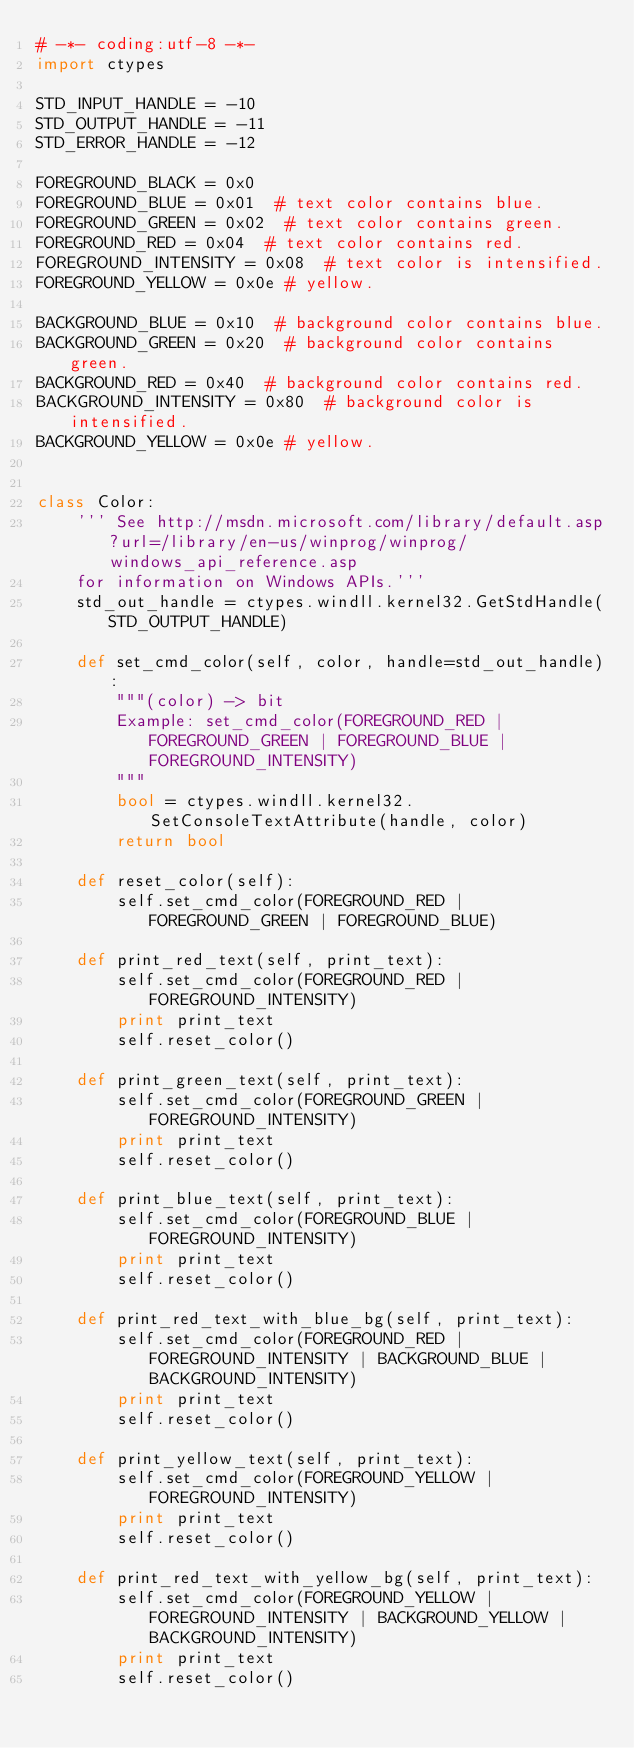Convert code to text. <code><loc_0><loc_0><loc_500><loc_500><_Python_># -*- coding:utf-8 -*-
import ctypes

STD_INPUT_HANDLE = -10
STD_OUTPUT_HANDLE = -11
STD_ERROR_HANDLE = -12

FOREGROUND_BLACK = 0x0
FOREGROUND_BLUE = 0x01  # text color contains blue.
FOREGROUND_GREEN = 0x02  # text color contains green.
FOREGROUND_RED = 0x04  # text color contains red.
FOREGROUND_INTENSITY = 0x08  # text color is intensified.
FOREGROUND_YELLOW = 0x0e # yellow.

BACKGROUND_BLUE = 0x10  # background color contains blue.
BACKGROUND_GREEN = 0x20  # background color contains green.
BACKGROUND_RED = 0x40  # background color contains red.
BACKGROUND_INTENSITY = 0x80  # background color is intensified.
BACKGROUND_YELLOW = 0x0e # yellow.


class Color:
    ''' See http://msdn.microsoft.com/library/default.asp?url=/library/en-us/winprog/winprog/windows_api_reference.asp
    for information on Windows APIs.'''
    std_out_handle = ctypes.windll.kernel32.GetStdHandle(STD_OUTPUT_HANDLE)

    def set_cmd_color(self, color, handle=std_out_handle):
        """(color) -> bit
        Example: set_cmd_color(FOREGROUND_RED | FOREGROUND_GREEN | FOREGROUND_BLUE | FOREGROUND_INTENSITY)
        """
        bool = ctypes.windll.kernel32.SetConsoleTextAttribute(handle, color)
        return bool

    def reset_color(self):
        self.set_cmd_color(FOREGROUND_RED | FOREGROUND_GREEN | FOREGROUND_BLUE)

    def print_red_text(self, print_text):
        self.set_cmd_color(FOREGROUND_RED | FOREGROUND_INTENSITY)
        print print_text
        self.reset_color()

    def print_green_text(self, print_text):
        self.set_cmd_color(FOREGROUND_GREEN | FOREGROUND_INTENSITY)
        print print_text
        self.reset_color()

    def print_blue_text(self, print_text):
        self.set_cmd_color(FOREGROUND_BLUE | FOREGROUND_INTENSITY)
        print print_text
        self.reset_color()

    def print_red_text_with_blue_bg(self, print_text):
        self.set_cmd_color(FOREGROUND_RED | FOREGROUND_INTENSITY | BACKGROUND_BLUE | BACKGROUND_INTENSITY)
        print print_text
        self.reset_color()

    def print_yellow_text(self, print_text):
        self.set_cmd_color(FOREGROUND_YELLOW | FOREGROUND_INTENSITY)
        print print_text
        self.reset_color()

    def print_red_text_with_yellow_bg(self, print_text):
        self.set_cmd_color(FOREGROUND_YELLOW | FOREGROUND_INTENSITY | BACKGROUND_YELLOW | BACKGROUND_INTENSITY)
        print print_text
        self.reset_color()</code> 